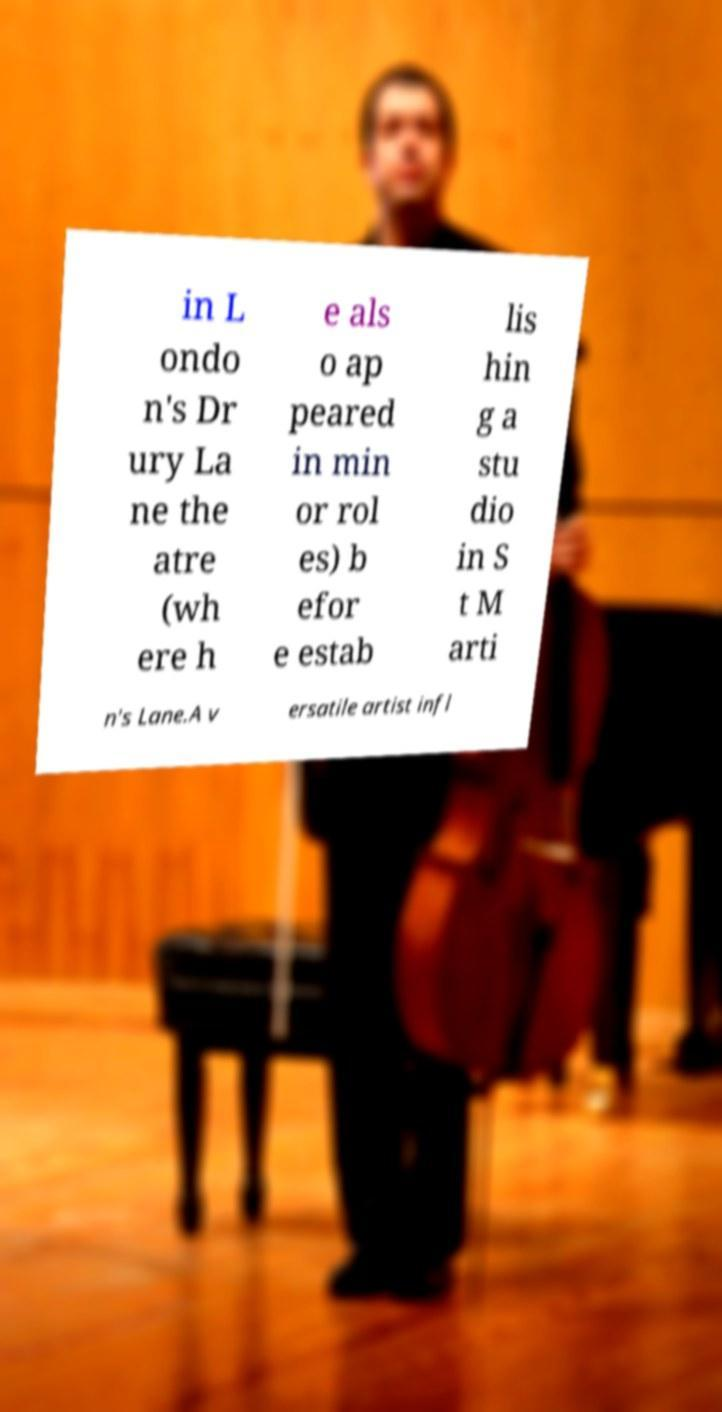Could you assist in decoding the text presented in this image and type it out clearly? in L ondo n's Dr ury La ne the atre (wh ere h e als o ap peared in min or rol es) b efor e estab lis hin g a stu dio in S t M arti n's Lane.A v ersatile artist infl 